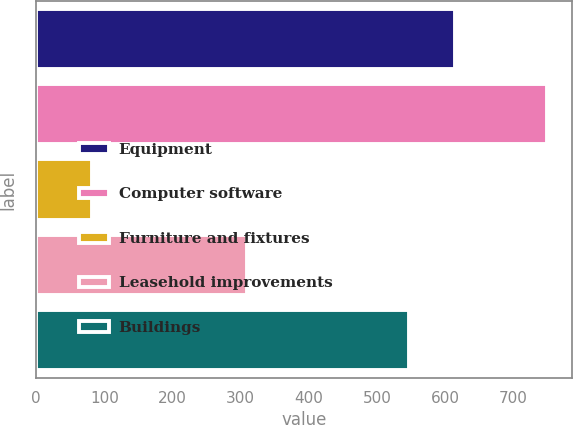Convert chart to OTSL. <chart><loc_0><loc_0><loc_500><loc_500><bar_chart><fcel>Equipment<fcel>Computer software<fcel>Furniture and fixtures<fcel>Leasehold improvements<fcel>Buildings<nl><fcel>613.7<fcel>749<fcel>82<fcel>310<fcel>547<nl></chart> 